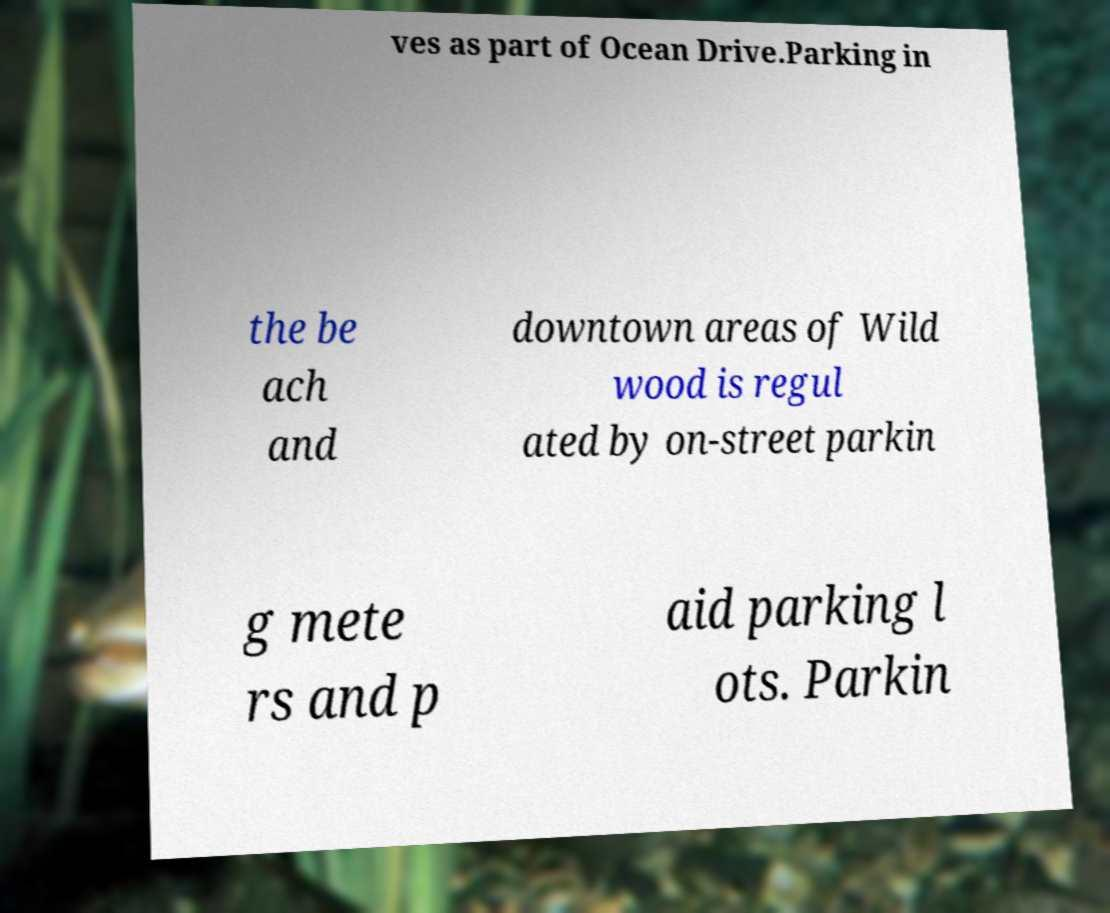For documentation purposes, I need the text within this image transcribed. Could you provide that? ves as part of Ocean Drive.Parking in the be ach and downtown areas of Wild wood is regul ated by on-street parkin g mete rs and p aid parking l ots. Parkin 